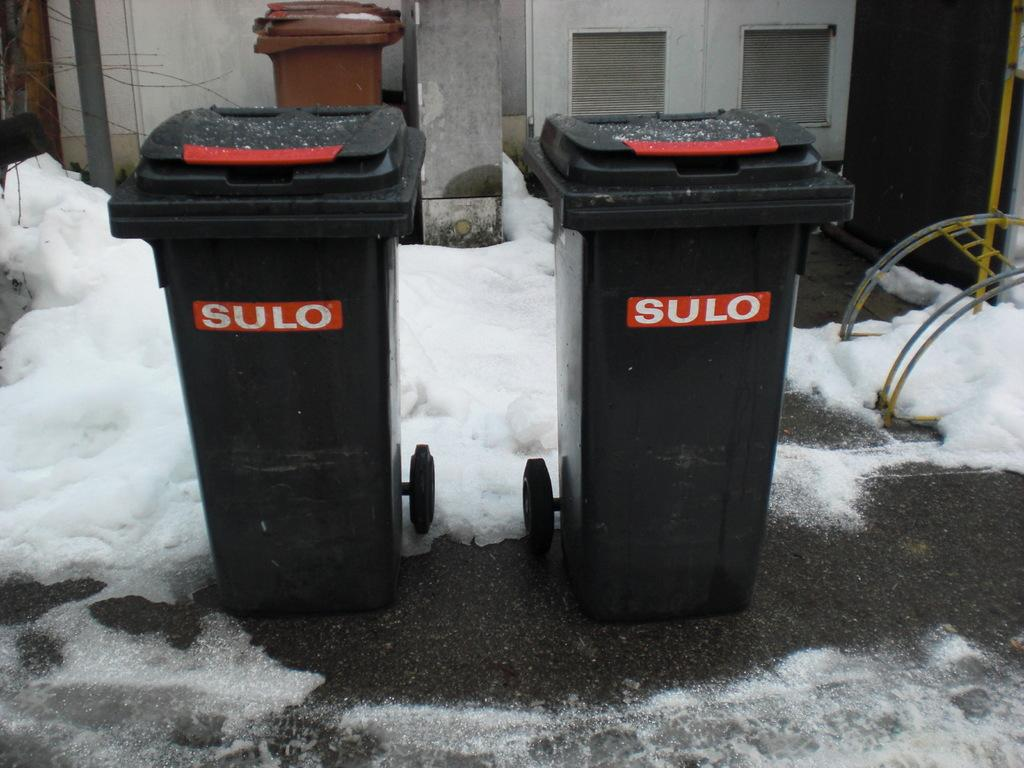<image>
Write a terse but informative summary of the picture. Two black garbage cans that says SULO on it. 